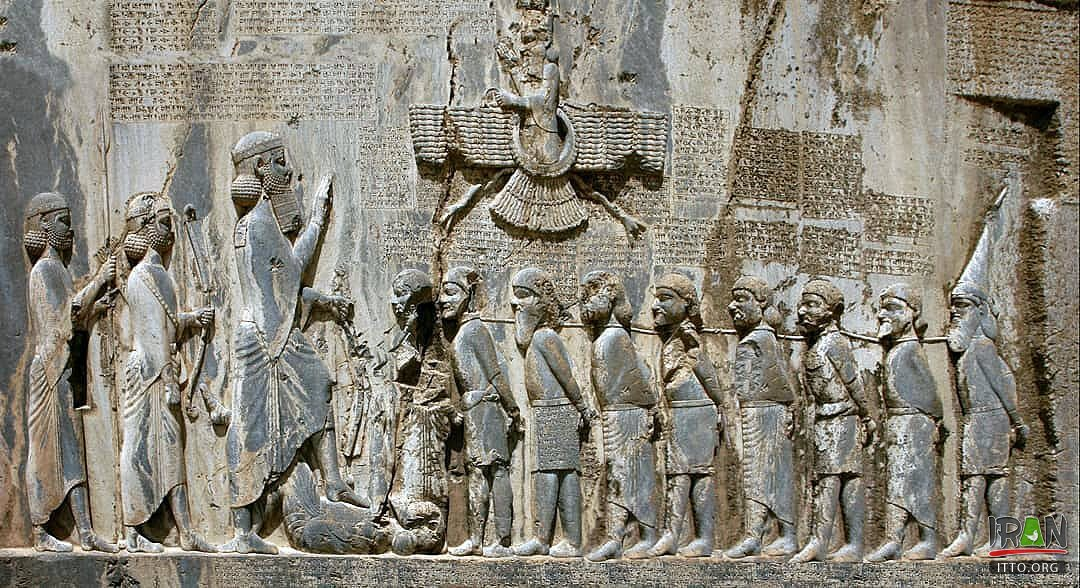Can you tell more about the symbolism behind the posture of Darius in this image? Certainly! Darius the Great is depicted with an assertive posture, standing with his left foot on the chest of a fallen enemy. This pose is not merely about physical dominance but serves a symbolic purpose of underscoring his power and ultimate authority over the defeated. The image conveys his role as a ruler who is both a military conqueror and a divinely sanctioned king, as evidenced by the faravahar symbol above him, signifying divine favor and kingship in Zoroastrianism. Such imagery was designed to communicate the might and rightness of Darius's rule to anyone who viewed it. 